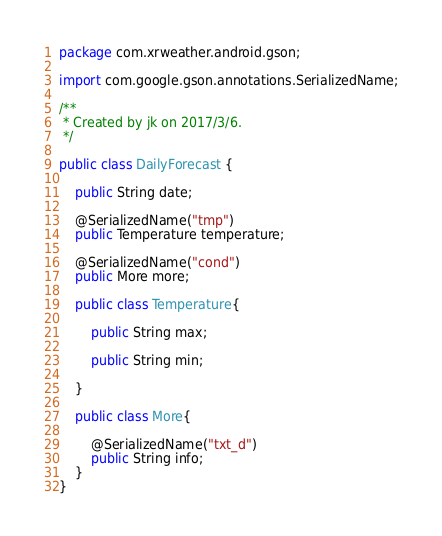Convert code to text. <code><loc_0><loc_0><loc_500><loc_500><_Java_>package com.xrweather.android.gson;

import com.google.gson.annotations.SerializedName;

/**
 * Created by jk on 2017/3/6.
 */

public class DailyForecast {

    public String date;

    @SerializedName("tmp")
    public Temperature temperature;

    @SerializedName("cond")
    public More more;

    public class Temperature{

        public String max;

        public String min;

    }

    public class More{

        @SerializedName("txt_d")
        public String info;
    }
}
</code> 